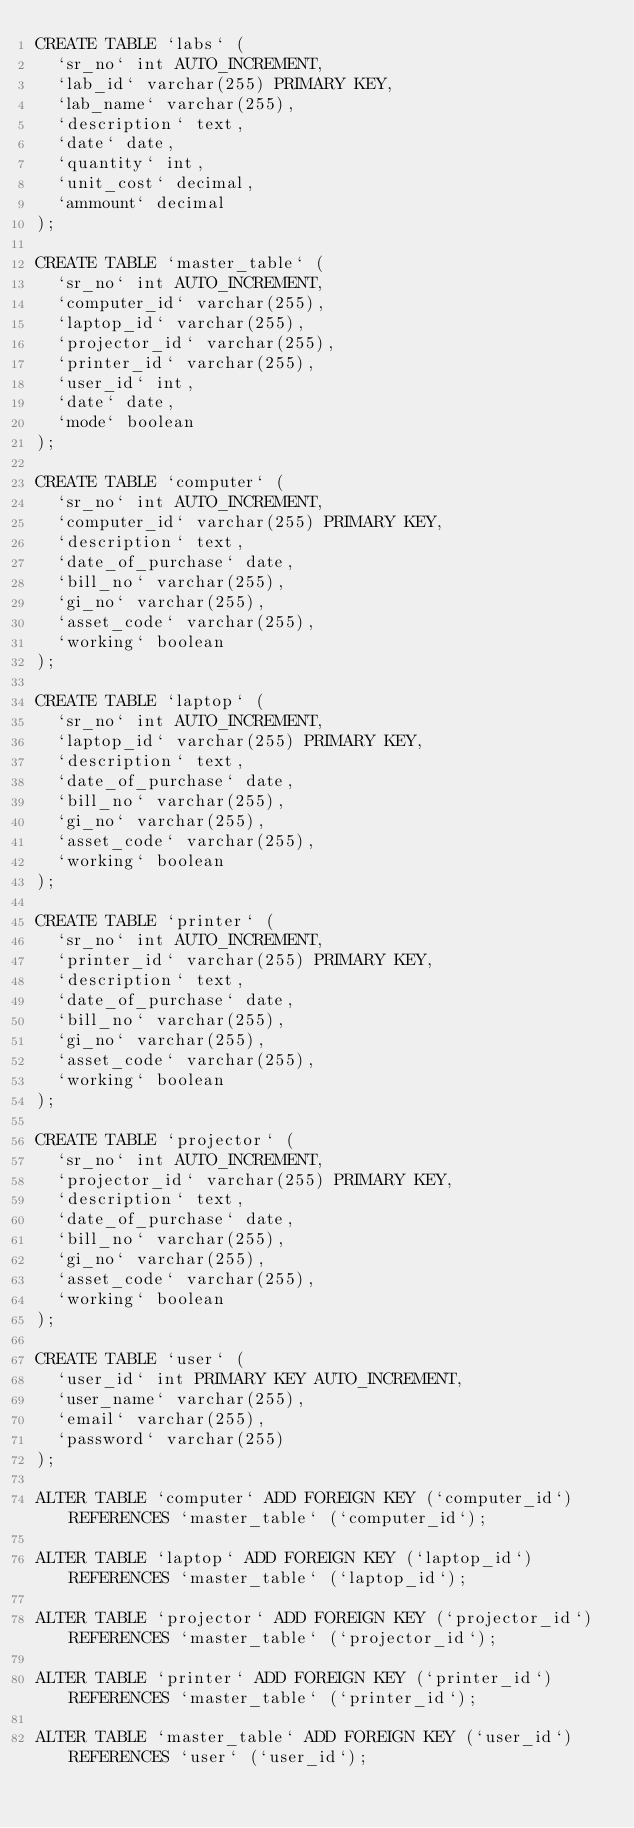<code> <loc_0><loc_0><loc_500><loc_500><_SQL_>CREATE TABLE `labs` (
  `sr_no` int AUTO_INCREMENT,
  `lab_id` varchar(255) PRIMARY KEY,
  `lab_name` varchar(255),
  `description` text,
  `date` date,
  `quantity` int,
  `unit_cost` decimal,
  `ammount` decimal
);

CREATE TABLE `master_table` (
  `sr_no` int AUTO_INCREMENT,
  `computer_id` varchar(255),
  `laptop_id` varchar(255),
  `projector_id` varchar(255),
  `printer_id` varchar(255),
  `user_id` int,
  `date` date,
  `mode` boolean
);

CREATE TABLE `computer` (
  `sr_no` int AUTO_INCREMENT,
  `computer_id` varchar(255) PRIMARY KEY,
  `description` text,
  `date_of_purchase` date,
  `bill_no` varchar(255),
  `gi_no` varchar(255),
  `asset_code` varchar(255),
  `working` boolean
);

CREATE TABLE `laptop` (
  `sr_no` int AUTO_INCREMENT,
  `laptop_id` varchar(255) PRIMARY KEY,
  `description` text,
  `date_of_purchase` date,
  `bill_no` varchar(255),
  `gi_no` varchar(255),
  `asset_code` varchar(255),
  `working` boolean
);

CREATE TABLE `printer` (
  `sr_no` int AUTO_INCREMENT,
  `printer_id` varchar(255) PRIMARY KEY,
  `description` text,
  `date_of_purchase` date,
  `bill_no` varchar(255),
  `gi_no` varchar(255),
  `asset_code` varchar(255),
  `working` boolean
);

CREATE TABLE `projector` (
  `sr_no` int AUTO_INCREMENT,
  `projector_id` varchar(255) PRIMARY KEY,
  `description` text,
  `date_of_purchase` date,
  `bill_no` varchar(255),
  `gi_no` varchar(255),
  `asset_code` varchar(255),
  `working` boolean
);

CREATE TABLE `user` (
  `user_id` int PRIMARY KEY AUTO_INCREMENT,
  `user_name` varchar(255),
  `email` varchar(255),
  `password` varchar(255)
);

ALTER TABLE `computer` ADD FOREIGN KEY (`computer_id`) REFERENCES `master_table` (`computer_id`);

ALTER TABLE `laptop` ADD FOREIGN KEY (`laptop_id`) REFERENCES `master_table` (`laptop_id`);

ALTER TABLE `projector` ADD FOREIGN KEY (`projector_id`) REFERENCES `master_table` (`projector_id`);

ALTER TABLE `printer` ADD FOREIGN KEY (`printer_id`) REFERENCES `master_table` (`printer_id`);

ALTER TABLE `master_table` ADD FOREIGN KEY (`user_id`) REFERENCES `user` (`user_id`);
</code> 